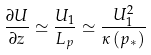Convert formula to latex. <formula><loc_0><loc_0><loc_500><loc_500>\frac { \partial U } { \partial z } \simeq \frac { U _ { 1 } } { L _ { p } } \simeq \frac { U _ { 1 } ^ { 2 } } { \kappa \left ( p _ { * } \right ) }</formula> 